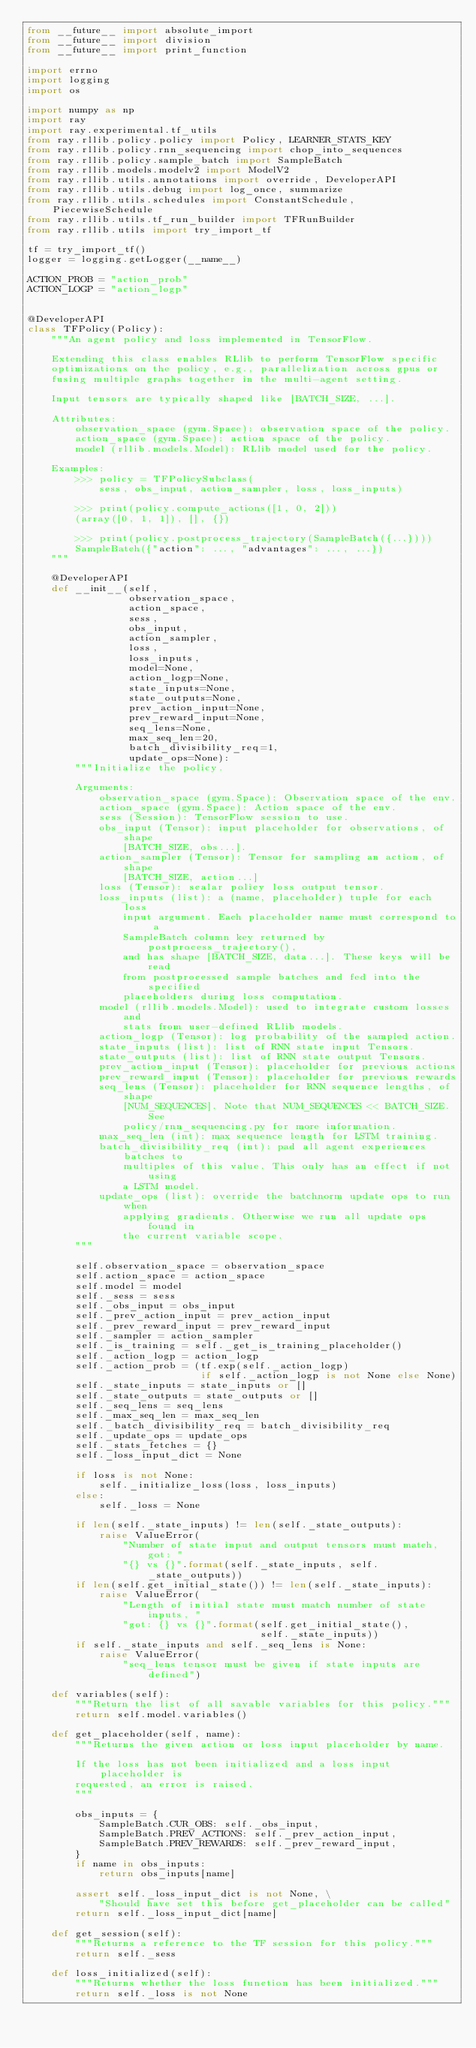<code> <loc_0><loc_0><loc_500><loc_500><_Python_>from __future__ import absolute_import
from __future__ import division
from __future__ import print_function

import errno
import logging
import os

import numpy as np
import ray
import ray.experimental.tf_utils
from ray.rllib.policy.policy import Policy, LEARNER_STATS_KEY
from ray.rllib.policy.rnn_sequencing import chop_into_sequences
from ray.rllib.policy.sample_batch import SampleBatch
from ray.rllib.models.modelv2 import ModelV2
from ray.rllib.utils.annotations import override, DeveloperAPI
from ray.rllib.utils.debug import log_once, summarize
from ray.rllib.utils.schedules import ConstantSchedule, PiecewiseSchedule
from ray.rllib.utils.tf_run_builder import TFRunBuilder
from ray.rllib.utils import try_import_tf

tf = try_import_tf()
logger = logging.getLogger(__name__)

ACTION_PROB = "action_prob"
ACTION_LOGP = "action_logp"


@DeveloperAPI
class TFPolicy(Policy):
    """An agent policy and loss implemented in TensorFlow.

    Extending this class enables RLlib to perform TensorFlow specific
    optimizations on the policy, e.g., parallelization across gpus or
    fusing multiple graphs together in the multi-agent setting.

    Input tensors are typically shaped like [BATCH_SIZE, ...].

    Attributes:
        observation_space (gym.Space): observation space of the policy.
        action_space (gym.Space): action space of the policy.
        model (rllib.models.Model): RLlib model used for the policy.

    Examples:
        >>> policy = TFPolicySubclass(
            sess, obs_input, action_sampler, loss, loss_inputs)

        >>> print(policy.compute_actions([1, 0, 2]))
        (array([0, 1, 1]), [], {})

        >>> print(policy.postprocess_trajectory(SampleBatch({...})))
        SampleBatch({"action": ..., "advantages": ..., ...})
    """

    @DeveloperAPI
    def __init__(self,
                 observation_space,
                 action_space,
                 sess,
                 obs_input,
                 action_sampler,
                 loss,
                 loss_inputs,
                 model=None,
                 action_logp=None,
                 state_inputs=None,
                 state_outputs=None,
                 prev_action_input=None,
                 prev_reward_input=None,
                 seq_lens=None,
                 max_seq_len=20,
                 batch_divisibility_req=1,
                 update_ops=None):
        """Initialize the policy.

        Arguments:
            observation_space (gym.Space): Observation space of the env.
            action_space (gym.Space): Action space of the env.
            sess (Session): TensorFlow session to use.
            obs_input (Tensor): input placeholder for observations, of shape
                [BATCH_SIZE, obs...].
            action_sampler (Tensor): Tensor for sampling an action, of shape
                [BATCH_SIZE, action...]
            loss (Tensor): scalar policy loss output tensor.
            loss_inputs (list): a (name, placeholder) tuple for each loss
                input argument. Each placeholder name must correspond to a
                SampleBatch column key returned by postprocess_trajectory(),
                and has shape [BATCH_SIZE, data...]. These keys will be read
                from postprocessed sample batches and fed into the specified
                placeholders during loss computation.
            model (rllib.models.Model): used to integrate custom losses and
                stats from user-defined RLlib models.
            action_logp (Tensor): log probability of the sampled action.
            state_inputs (list): list of RNN state input Tensors.
            state_outputs (list): list of RNN state output Tensors.
            prev_action_input (Tensor): placeholder for previous actions
            prev_reward_input (Tensor): placeholder for previous rewards
            seq_lens (Tensor): placeholder for RNN sequence lengths, of shape
                [NUM_SEQUENCES]. Note that NUM_SEQUENCES << BATCH_SIZE. See
                policy/rnn_sequencing.py for more information.
            max_seq_len (int): max sequence length for LSTM training.
            batch_divisibility_req (int): pad all agent experiences batches to
                multiples of this value. This only has an effect if not using
                a LSTM model.
            update_ops (list): override the batchnorm update ops to run when
                applying gradients. Otherwise we run all update ops found in
                the current variable scope.
        """

        self.observation_space = observation_space
        self.action_space = action_space
        self.model = model
        self._sess = sess
        self._obs_input = obs_input
        self._prev_action_input = prev_action_input
        self._prev_reward_input = prev_reward_input
        self._sampler = action_sampler
        self._is_training = self._get_is_training_placeholder()
        self._action_logp = action_logp
        self._action_prob = (tf.exp(self._action_logp)
                             if self._action_logp is not None else None)
        self._state_inputs = state_inputs or []
        self._state_outputs = state_outputs or []
        self._seq_lens = seq_lens
        self._max_seq_len = max_seq_len
        self._batch_divisibility_req = batch_divisibility_req
        self._update_ops = update_ops
        self._stats_fetches = {}
        self._loss_input_dict = None

        if loss is not None:
            self._initialize_loss(loss, loss_inputs)
        else:
            self._loss = None

        if len(self._state_inputs) != len(self._state_outputs):
            raise ValueError(
                "Number of state input and output tensors must match, got: "
                "{} vs {}".format(self._state_inputs, self._state_outputs))
        if len(self.get_initial_state()) != len(self._state_inputs):
            raise ValueError(
                "Length of initial state must match number of state inputs, "
                "got: {} vs {}".format(self.get_initial_state(),
                                       self._state_inputs))
        if self._state_inputs and self._seq_lens is None:
            raise ValueError(
                "seq_lens tensor must be given if state inputs are defined")

    def variables(self):
        """Return the list of all savable variables for this policy."""
        return self.model.variables()

    def get_placeholder(self, name):
        """Returns the given action or loss input placeholder by name.

        If the loss has not been initialized and a loss input placeholder is
        requested, an error is raised.
        """

        obs_inputs = {
            SampleBatch.CUR_OBS: self._obs_input,
            SampleBatch.PREV_ACTIONS: self._prev_action_input,
            SampleBatch.PREV_REWARDS: self._prev_reward_input,
        }
        if name in obs_inputs:
            return obs_inputs[name]

        assert self._loss_input_dict is not None, \
            "Should have set this before get_placeholder can be called"
        return self._loss_input_dict[name]

    def get_session(self):
        """Returns a reference to the TF session for this policy."""
        return self._sess

    def loss_initialized(self):
        """Returns whether the loss function has been initialized."""
        return self._loss is not None
</code> 